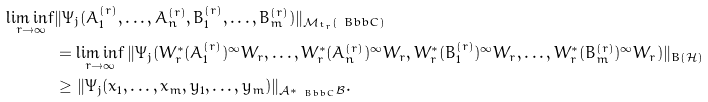<formula> <loc_0><loc_0><loc_500><loc_500>\liminf _ { r \rightarrow \infty } & \| \Psi _ { j } ( A _ { 1 } ^ { ( r ) } , \dots , A _ { n } ^ { ( r ) } , B _ { 1 } ^ { ( r ) } , \dots , B _ { m } ^ { ( r ) } ) \| _ { \mathcal { M } _ { t _ { r } } ( \ B b b C ) } \\ & = \liminf _ { r \rightarrow \infty } \| \Psi _ { j } ( W _ { r } ^ { * } ( A _ { 1 } ^ { ( r ) } ) ^ { \infty } W _ { r } , \dots , W _ { r } ^ { * } ( A _ { n } ^ { ( r ) } ) ^ { \infty } W _ { r } , W _ { r } ^ { * } ( B _ { 1 } ^ { ( r ) } ) ^ { \infty } W _ { r } , \dots , W _ { r } ^ { * } ( B _ { m } ^ { ( r ) } ) ^ { \infty } W _ { r } ) \| _ { B ( \mathcal { H } ) } \\ & \geq \| \Psi _ { j } ( x _ { 1 } , \dots , x _ { m } , y _ { 1 } , \dots , y _ { m } ) \| _ { \mathcal { A } * _ { \ B b b C } \mathcal { B } } .</formula> 